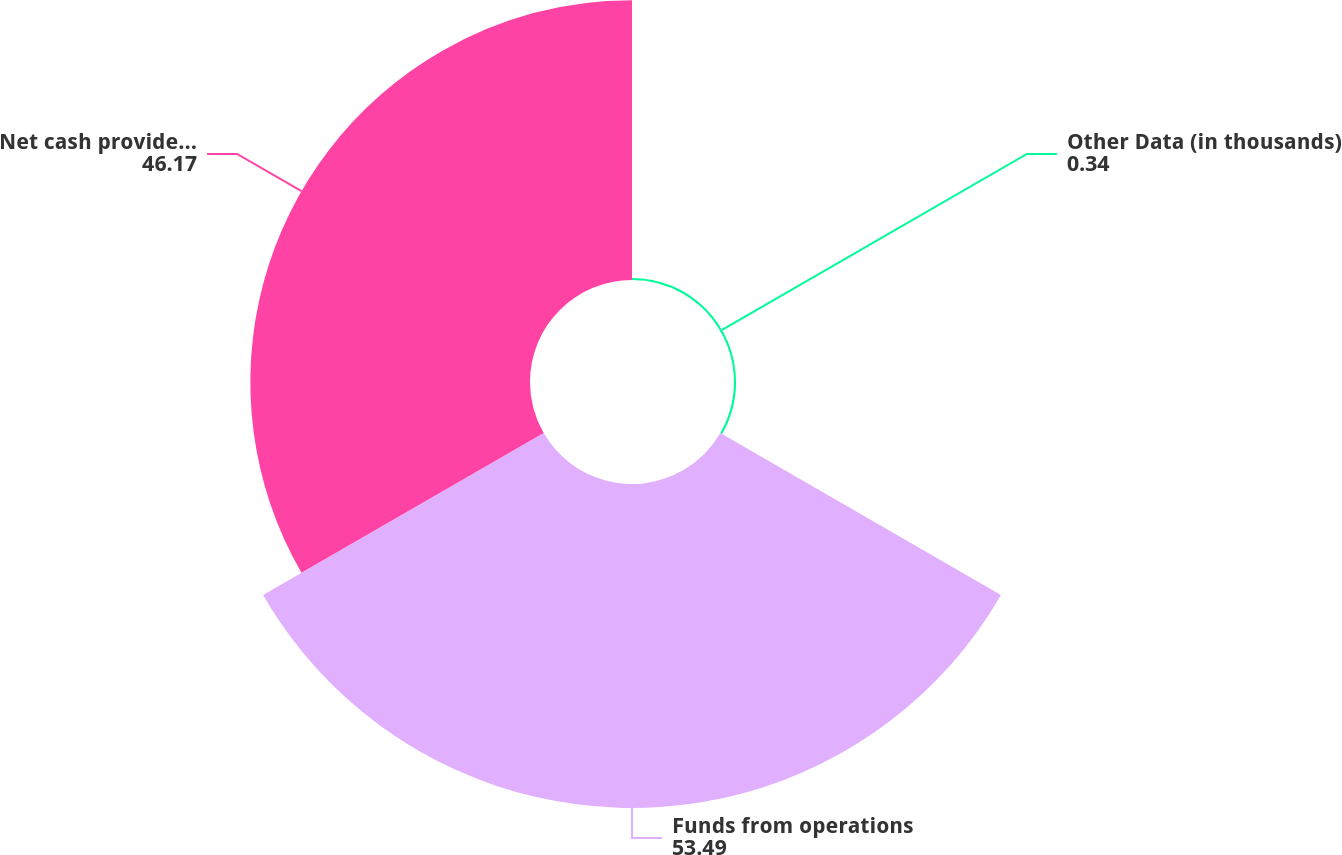<chart> <loc_0><loc_0><loc_500><loc_500><pie_chart><fcel>Other Data (in thousands)<fcel>Funds from operations<fcel>Net cash provided by operating<nl><fcel>0.34%<fcel>53.49%<fcel>46.17%<nl></chart> 